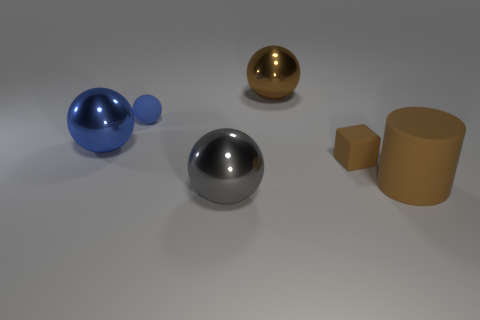How would the objects in this image interact if they were in a physical environment? If these objects were placed in a physical environment, their interactions would depend on their material properties and gravity. The blue and silver spheres would likely roll if placed on an inclined surface due to their smooth, curved surfaces. The golden object, assuming it is also spherical, would behave similarly. The cylinder, with its flat bases, would remain stationary unless tipped over. Meanwhile, the small brown cube, with its flat sides, would stay put unless acted upon by an external force such as a push. 